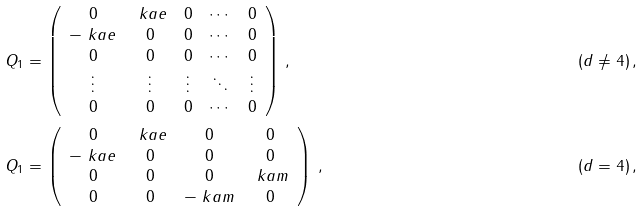Convert formula to latex. <formula><loc_0><loc_0><loc_500><loc_500>Q _ { 1 } & = \left ( \begin{array} { c c c c c } 0 & \ k a e & 0 & \cdots & 0 \\ - \ k a e & 0 & 0 & \cdots & 0 \\ 0 & 0 & 0 & \cdots & 0 \\ \vdots & \vdots & \vdots & \ddots & \vdots \\ 0 & 0 & 0 & \cdots & 0 \end{array} \right ) \, , & ( d & \neq 4 ) \, , \\ Q _ { 1 } & = \left ( \begin{array} { c c c c } 0 & \ k a e & 0 & 0 \\ - \ k a e & 0 & 0 & 0 \\ 0 & 0 & 0 & \ k a m \\ 0 & 0 & - \ k a m & 0 \end{array} \right ) \, , & ( d & = 4 ) \, ,</formula> 